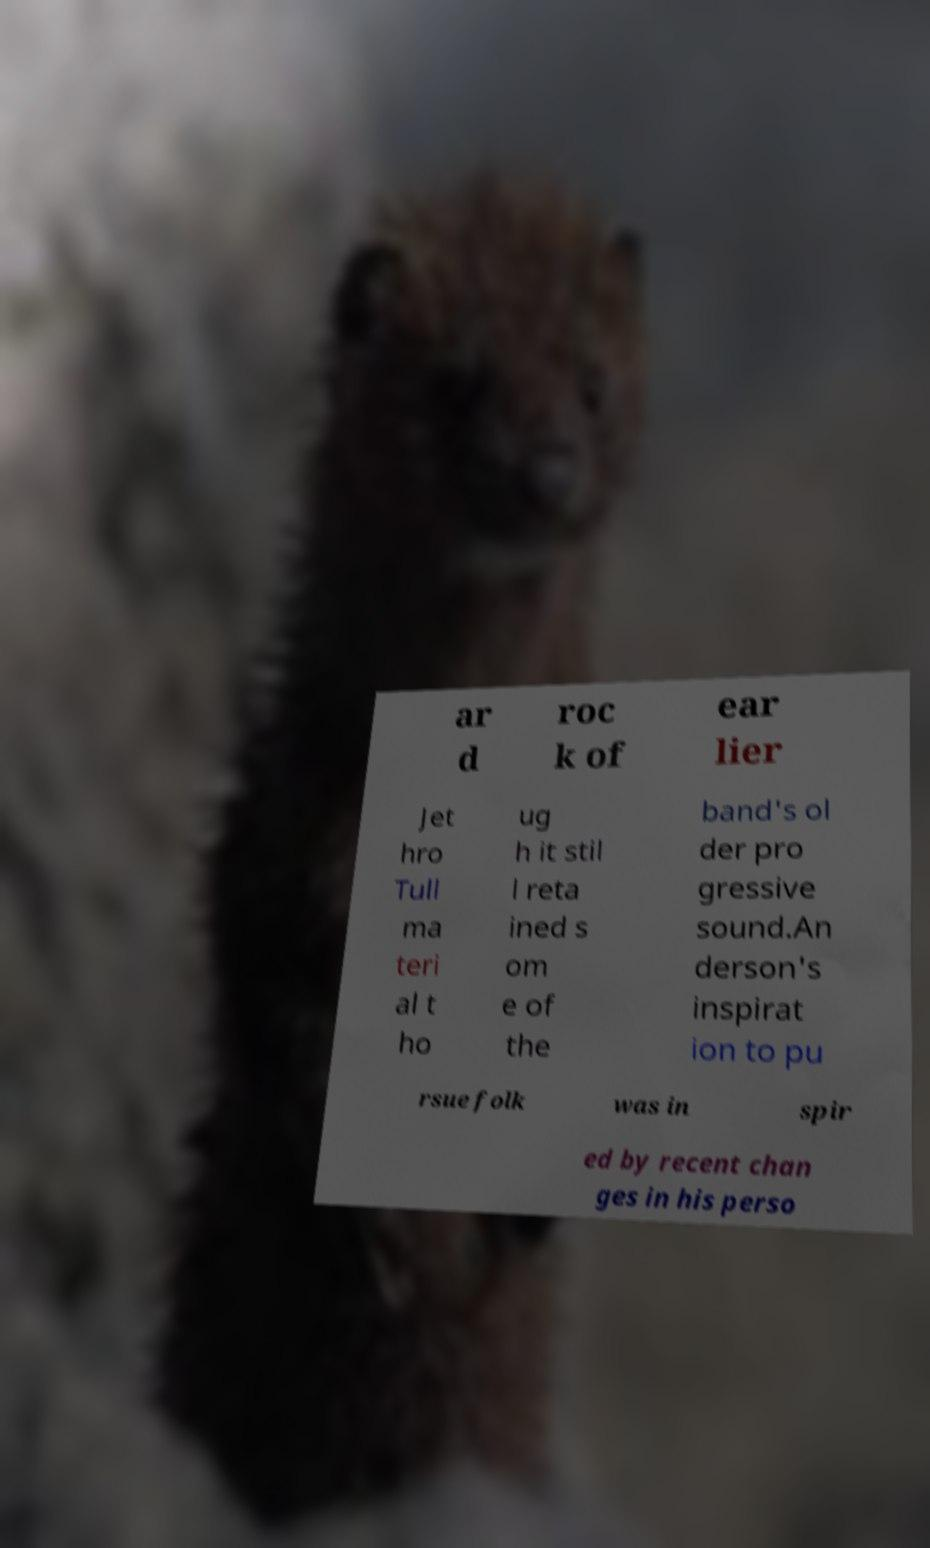Please identify and transcribe the text found in this image. ar d roc k of ear lier Jet hro Tull ma teri al t ho ug h it stil l reta ined s om e of the band's ol der pro gressive sound.An derson's inspirat ion to pu rsue folk was in spir ed by recent chan ges in his perso 